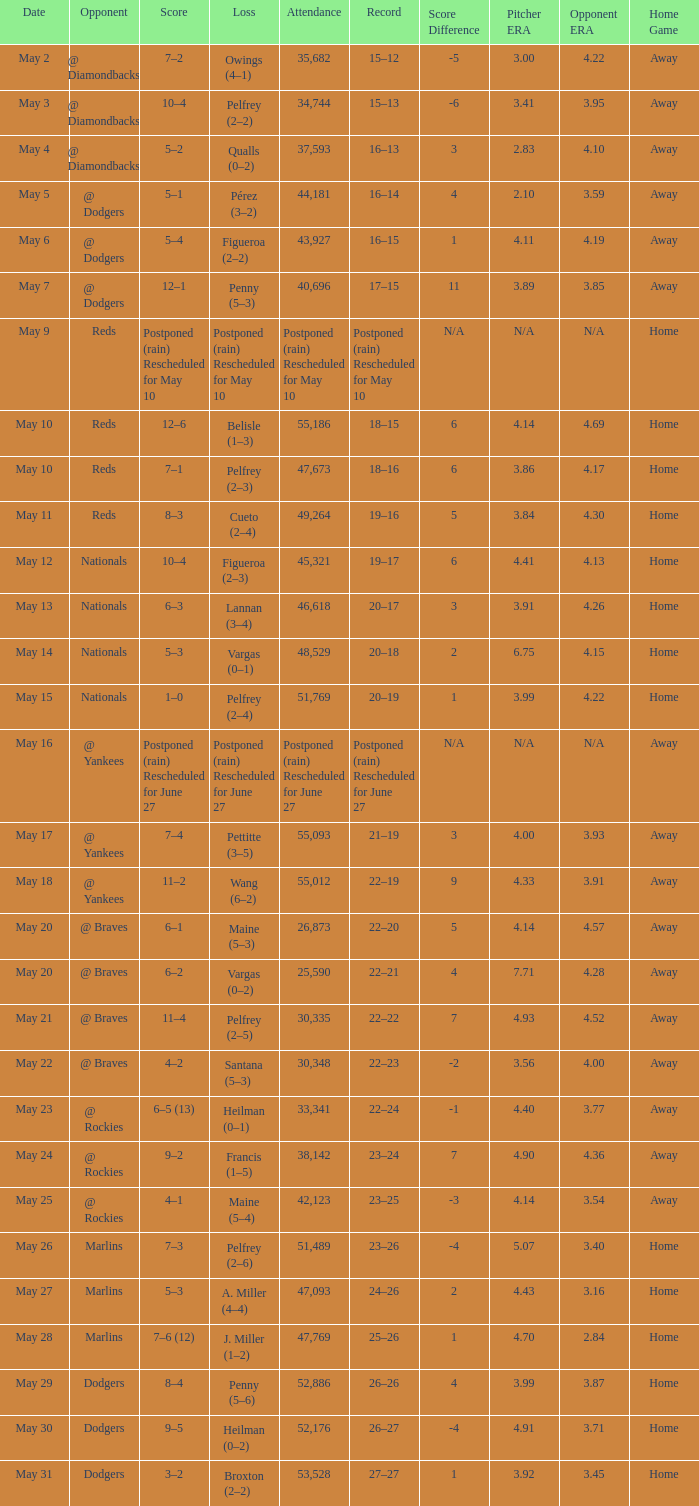Score of postponed (rain) rescheduled for June 27 had what loss? Postponed (rain) Rescheduled for June 27. 